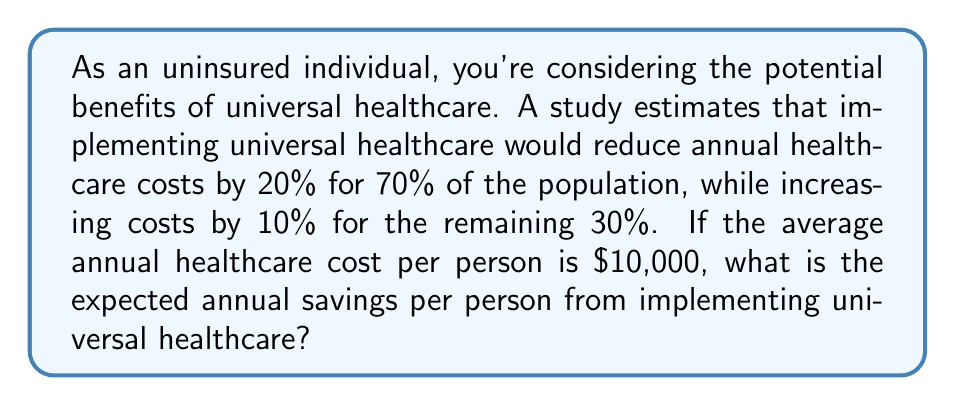Could you help me with this problem? Let's approach this step-by-step:

1) First, let's define our variables:
   $p_1 = 0.70$ (70% of population with reduced costs)
   $p_2 = 0.30$ (30% of population with increased costs)
   $c = \$10,000$ (average annual healthcare cost per person)

2) For the group with reduced costs:
   Savings = $0.20 * c * p_1 = 0.20 * \$10,000 * 0.70 = \$1,400$

3) For the group with increased costs:
   Additional cost = $0.10 * c * p_2 = 0.10 * \$10,000 * 0.30 = \$300$

4) The expected savings is the difference between these two:
   Expected savings = $\$1,400 - \$300 = \$1,100$

5) We can also express this as an equation:
   $$E(\text{savings}) = (r_1 * c * p_1) - (r_2 * c * p_2)$$
   Where $r_1$ is the rate of cost reduction and $r_2$ is the rate of cost increase.

6) Plugging in our values:
   $$E(\text{savings}) = (0.20 * \$10,000 * 0.70) - (0.10 * \$10,000 * 0.30) = \$1,100$$

Therefore, the expected annual savings per person from implementing universal healthcare is $1,100.
Answer: $1,100 